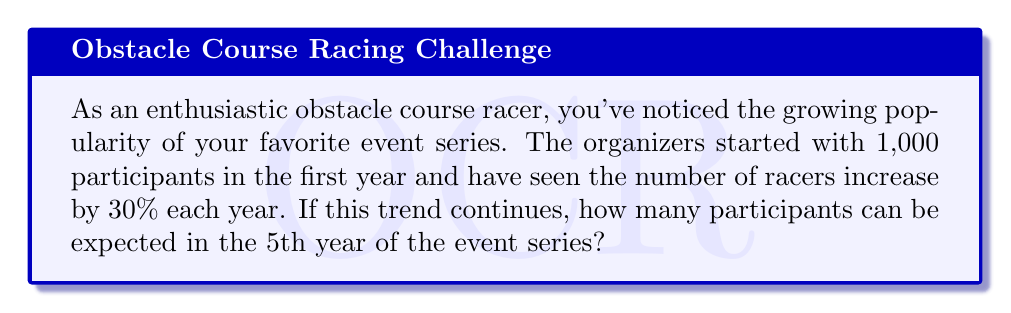Help me with this question. To solve this problem, we'll use an exponential growth model. The general form of an exponential growth model is:

$$ A = P(1 + r)^t $$

Where:
$A$ = Final amount
$P$ = Initial amount (principal)
$r$ = Growth rate (as a decimal)
$t$ = Time period

Given:
$P = 1,000$ (initial participants)
$r = 0.30$ (30% growth rate)
$t = 4$ (we want the 5th year, which is 4 years of growth from the initial year)

Let's plug these values into our equation:

$$ A = 1,000(1 + 0.30)^4 $$

Now, let's solve step-by-step:

1) First, calculate $(1 + 0.30)$:
   $1 + 0.30 = 1.30$

2) Now our equation looks like:
   $$ A = 1,000(1.30)^4 $$

3) Calculate $(1.30)^4$:
   $(1.30)^4 = 2.8561$

4) Finally, multiply by 1,000:
   $1,000 * 2.8561 = 2,856.1$

5) Since we can't have a fractional participant, we round to the nearest whole number:
   $2,856.1 \approx 2,856$
Answer: Approximately 2,856 participants can be expected in the 5th year of the event series. 